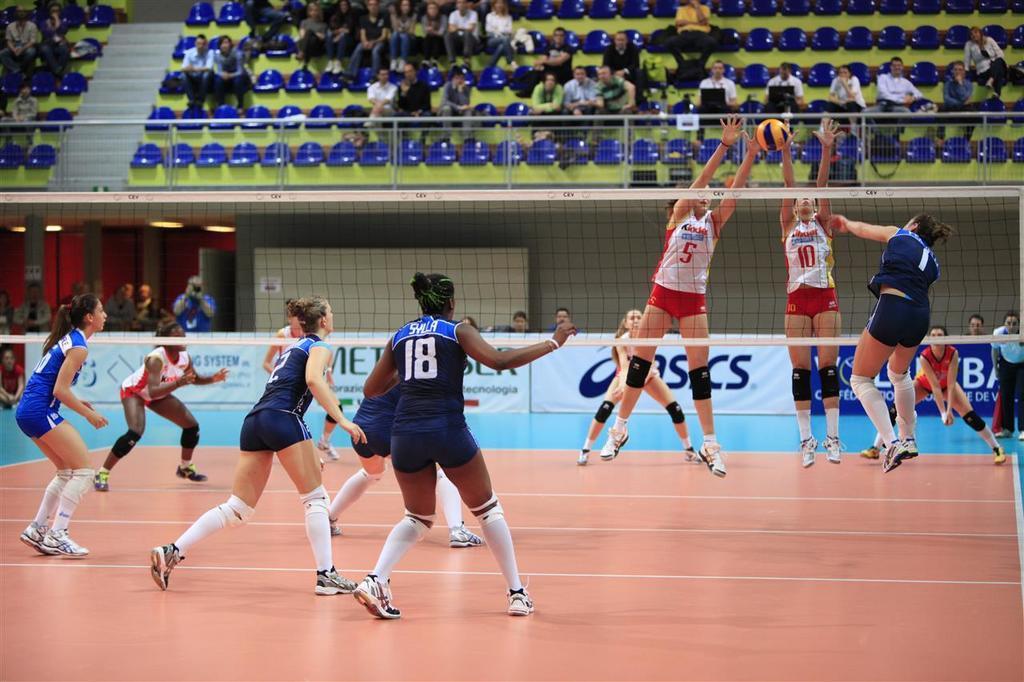Describe this image in one or two sentences. On the left side few girls are running, they wore blue color dresses. On the right side 2 girls are jumping, they wore white color tops. 